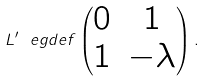Convert formula to latex. <formula><loc_0><loc_0><loc_500><loc_500>L ^ { \prime } \ e g d e f \begin{pmatrix} 0 & 1 \\ 1 & - \lambda \end{pmatrix} .</formula> 